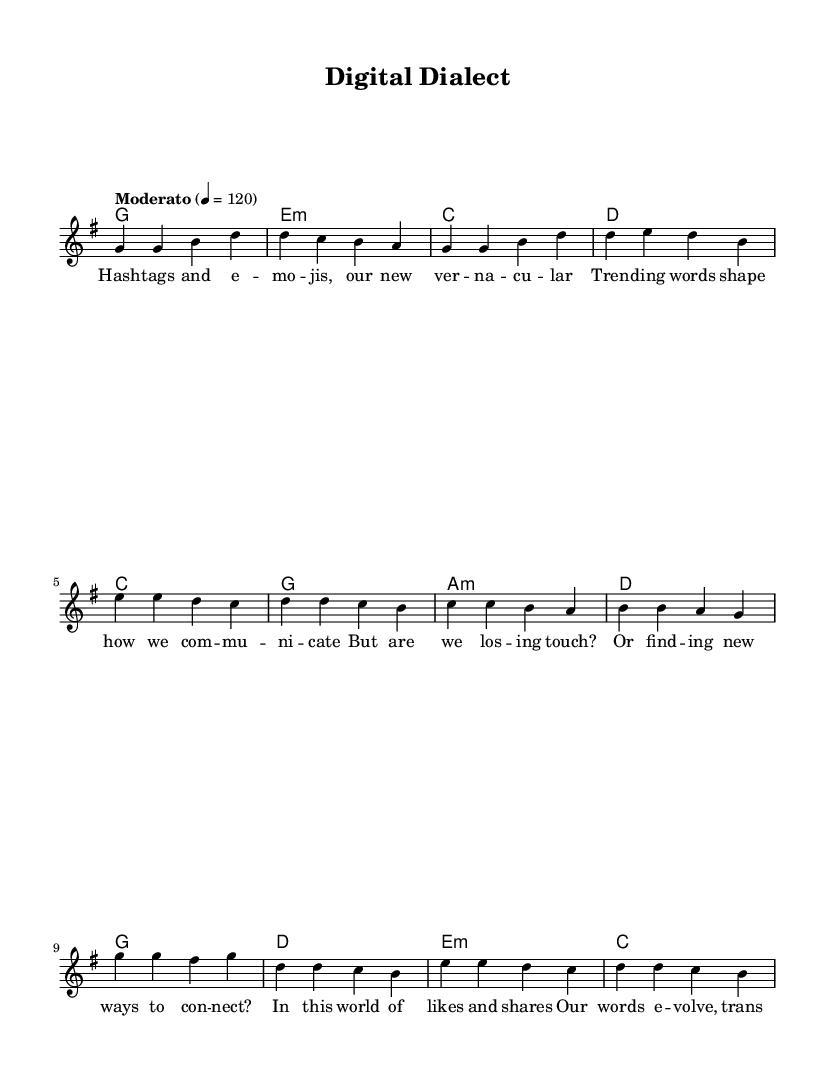What is the key signature of this music? The key signature is G major, which has one sharp (F#). This is identified in the global music section where it states "\key g \major".
Answer: G major What is the time signature of this piece? The time signature is 4/4, which indicates there are four beats in each measure and a quarter note receives one beat. This can be found in the global music section where "\time 4/4" is specified.
Answer: 4/4 What is the tempo marking of this composition? The tempo marking indicates a "Moderato" tempo, which means moderate speed, set at a quarter note equals 120 beats per minute. This is noted in the global section with the tempo instruction "Moderato" 4 = 120.
Answer: Moderato What chords are used in the pre-chorus? The chords used in the pre-chorus are C, G, A minor, and D. These can be identified in the harmony section where each measure is labeled with corresponding chord notations under the pre-chorus melody.
Answer: C, G, A minor, D What lyrical theme does this piece explore? The lyrical theme of this piece explores the impact of social media on language and communication, highlighting trends in vocabulary and the adaptation of new ways to connect. This can be derived from the words used in the lyrics section which reference hashtags, emojis, and the evolution of communication.
Answer: Impact of social media 